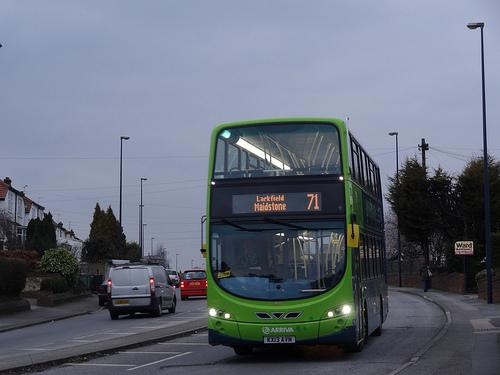Question: when was the photo taken?
Choices:
A. Midday.
B. Sunrise.
C. Night.
D. After Dinner.
Answer with the letter. Answer: C Question: what number is on the bus?
Choices:
A. 101.
B. 5.
C. 71.
D. 33.
Answer with the letter. Answer: C Question: what direction is the bus going?
Choices:
A. East.
B. South.
C. West.
D. Northeast.
Answer with the letter. Answer: B 